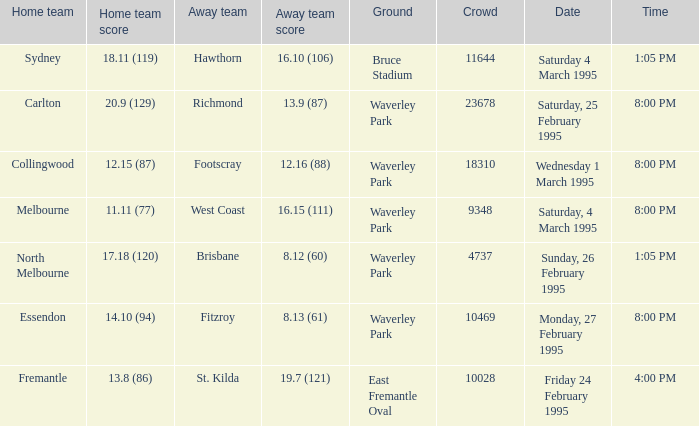Help me parse the entirety of this table. {'header': ['Home team', 'Home team score', 'Away team', 'Away team score', 'Ground', 'Crowd', 'Date', 'Time'], 'rows': [['Sydney', '18.11 (119)', 'Hawthorn', '16.10 (106)', 'Bruce Stadium', '11644', 'Saturday 4 March 1995', '1:05 PM'], ['Carlton', '20.9 (129)', 'Richmond', '13.9 (87)', 'Waverley Park', '23678', 'Saturday, 25 February 1995', '8:00 PM'], ['Collingwood', '12.15 (87)', 'Footscray', '12.16 (88)', 'Waverley Park', '18310', 'Wednesday 1 March 1995', '8:00 PM'], ['Melbourne', '11.11 (77)', 'West Coast', '16.15 (111)', 'Waverley Park', '9348', 'Saturday, 4 March 1995', '8:00 PM'], ['North Melbourne', '17.18 (120)', 'Brisbane', '8.12 (60)', 'Waverley Park', '4737', 'Sunday, 26 February 1995', '1:05 PM'], ['Essendon', '14.10 (94)', 'Fitzroy', '8.13 (61)', 'Waverley Park', '10469', 'Monday, 27 February 1995', '8:00 PM'], ['Fremantle', '13.8 (86)', 'St. Kilda', '19.7 (121)', 'East Fremantle Oval', '10028', 'Friday 24 February 1995', '4:00 PM']]} Name the time for saturday 4 march 1995 1:05 PM. 